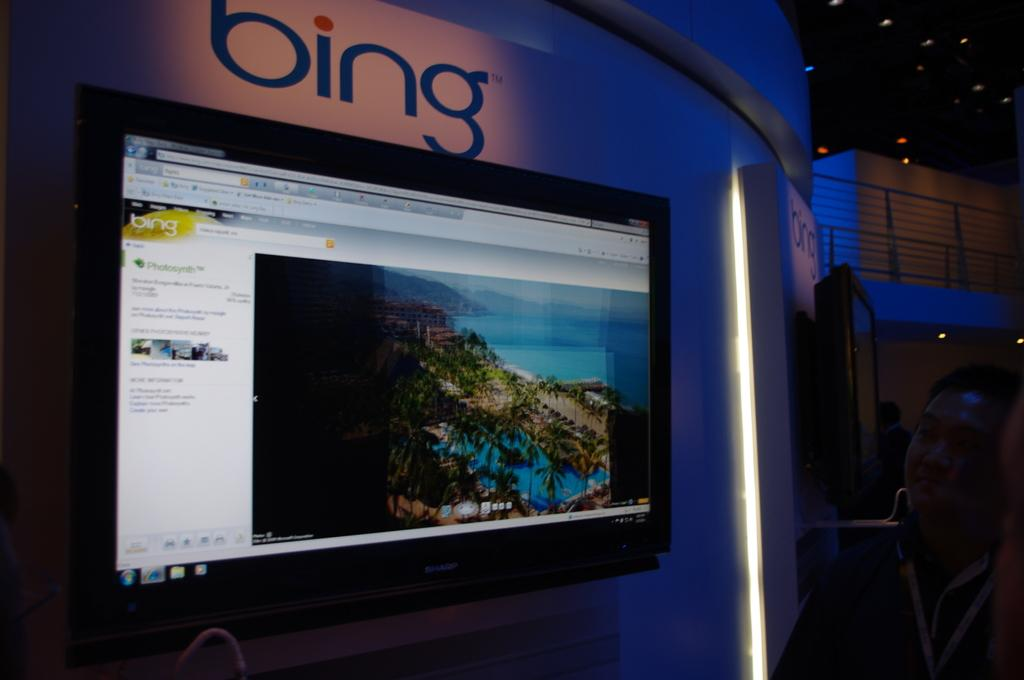What is on the wall in the image? There is a screen on the wall in the image. Where is the person located in the image? The person is standing on the right side of the image. What is the person doing in the image? The person is staring at the screen. What can be seen above the ceiling in the image? There are lights over the ceiling in the image. What color is the sweater the person is wearing in the image? There is no information about the person's clothing in the provided facts, so we cannot determine the color of their sweater. What type of paste is being used by the person in the image? There is no paste or any indication of its use in the image. 